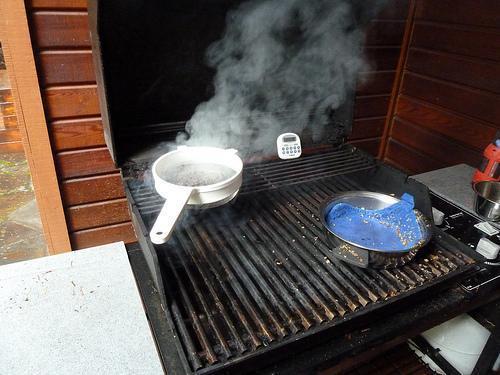How many white pans?
Give a very brief answer. 1. 